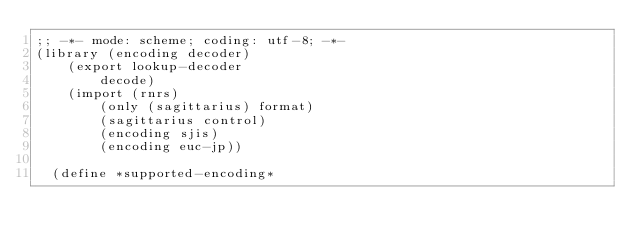<code> <loc_0><loc_0><loc_500><loc_500><_Scheme_>;; -*- mode: scheme; coding: utf-8; -*-
(library (encoding decoder)
    (export lookup-decoder
	    decode)
    (import (rnrs)
	    (only (sagittarius) format)
	    (sagittarius control)
	    (encoding sjis)
	    (encoding euc-jp))

  (define *supported-encoding*</code> 